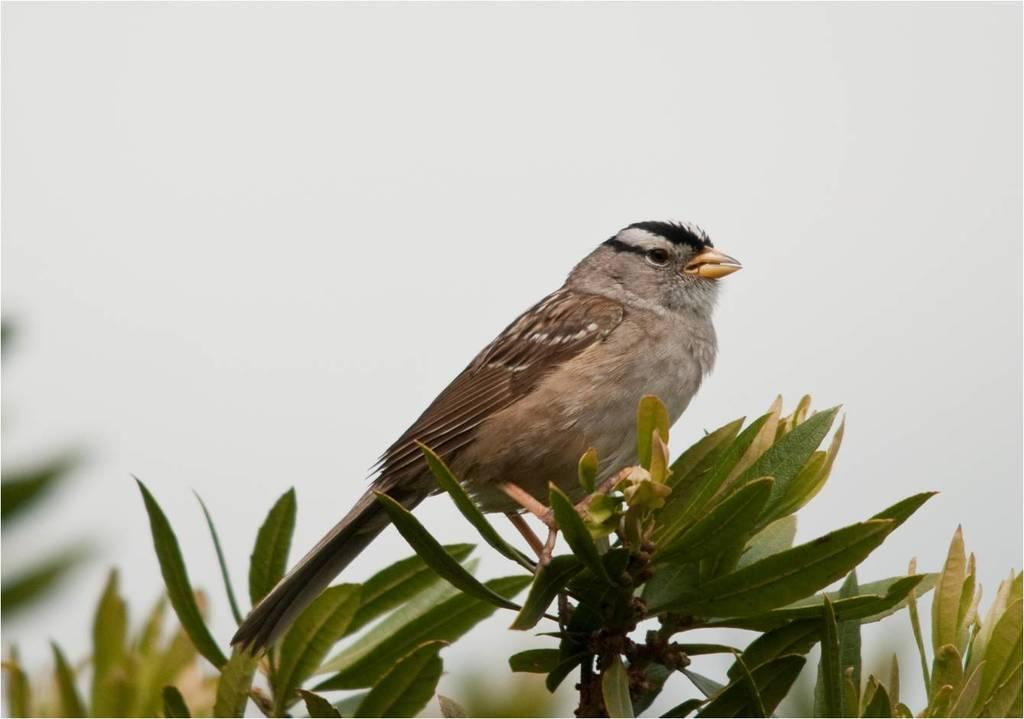What type of animal can be seen in the image? There is a bird in the image. Where is the bird located in the image? The bird is sitting on the stem of a plant. Can you describe the plant in the image? The plant has many leaves. What type of trade is happening between the bird and the plant in the image? There is no trade happening between the bird and the plant in the image; the bird is simply sitting on the stem of the plant. 